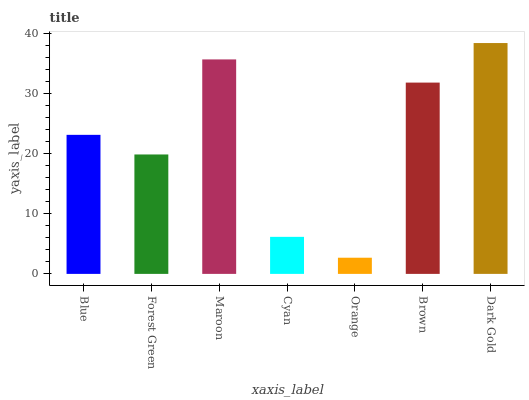Is Orange the minimum?
Answer yes or no. Yes. Is Dark Gold the maximum?
Answer yes or no. Yes. Is Forest Green the minimum?
Answer yes or no. No. Is Forest Green the maximum?
Answer yes or no. No. Is Blue greater than Forest Green?
Answer yes or no. Yes. Is Forest Green less than Blue?
Answer yes or no. Yes. Is Forest Green greater than Blue?
Answer yes or no. No. Is Blue less than Forest Green?
Answer yes or no. No. Is Blue the high median?
Answer yes or no. Yes. Is Blue the low median?
Answer yes or no. Yes. Is Brown the high median?
Answer yes or no. No. Is Cyan the low median?
Answer yes or no. No. 